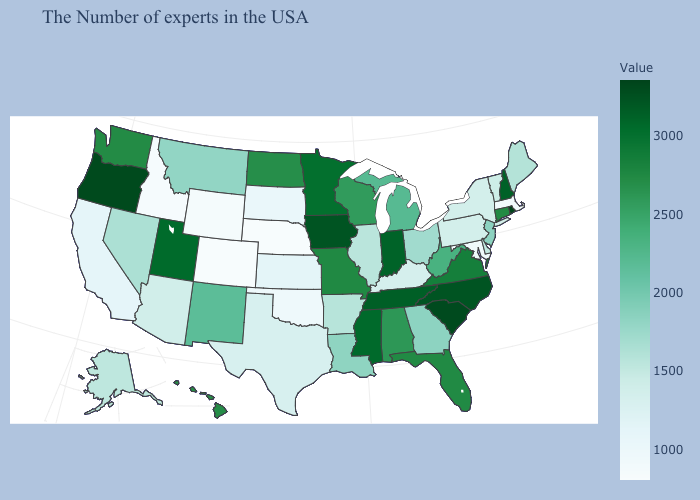Does the map have missing data?
Answer briefly. No. Which states have the lowest value in the MidWest?
Be succinct. Nebraska. Does Colorado have the lowest value in the USA?
Quick response, please. Yes. 